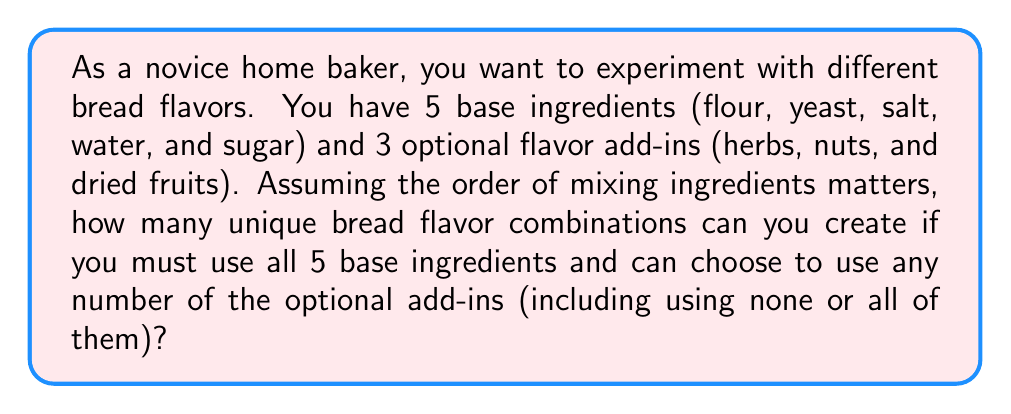What is the answer to this math problem? Let's approach this step-by-step using permutation groups:

1) First, we need to consider the base ingredients. Since we must use all 5 and the order matters, this is a straightforward permutation:
   $$P(5) = 5! = 5 \times 4 \times 3 \times 2 \times 1 = 120$$

2) Now, for the optional add-ins, we have 3 choices for each: use it or don't use it. This can be represented as a binary choice for each add-in, giving us $2^3 = 8$ possibilities for the optional ingredients.

3) For each of these 8 possibilities of optional ingredients, we need to consider how many ways we can arrange them with the base ingredients. Let's consider each case:

   - Using 0 add-ins: 1 way to arrange (just the base ingredients)
   - Using 1 add-in: 6 ways to arrange (the add-in can go in any of 6 positions)
   - Using 2 add-ins: 7 ways to arrange (7 positions for 2 add-ins)
   - Using 3 add-ins: 8 ways to arrange (8 positions for 3 add-ins)

4) The total number of arrangements for the optional ingredients is thus:
   $${3 \choose 0} \times 1 + {3 \choose 1} \times 6 + {3 \choose 2} \times 7 + {3 \choose 3} \times 8 = 1 + 18 + 21 + 8 = 48$$

5) By the multiplication principle, the total number of unique bread flavor combinations is:
   $$120 \times 48 = 5,760$$

Therefore, you can create 5,760 unique bread flavor combinations.
Answer: 5,760 unique bread flavor combinations 